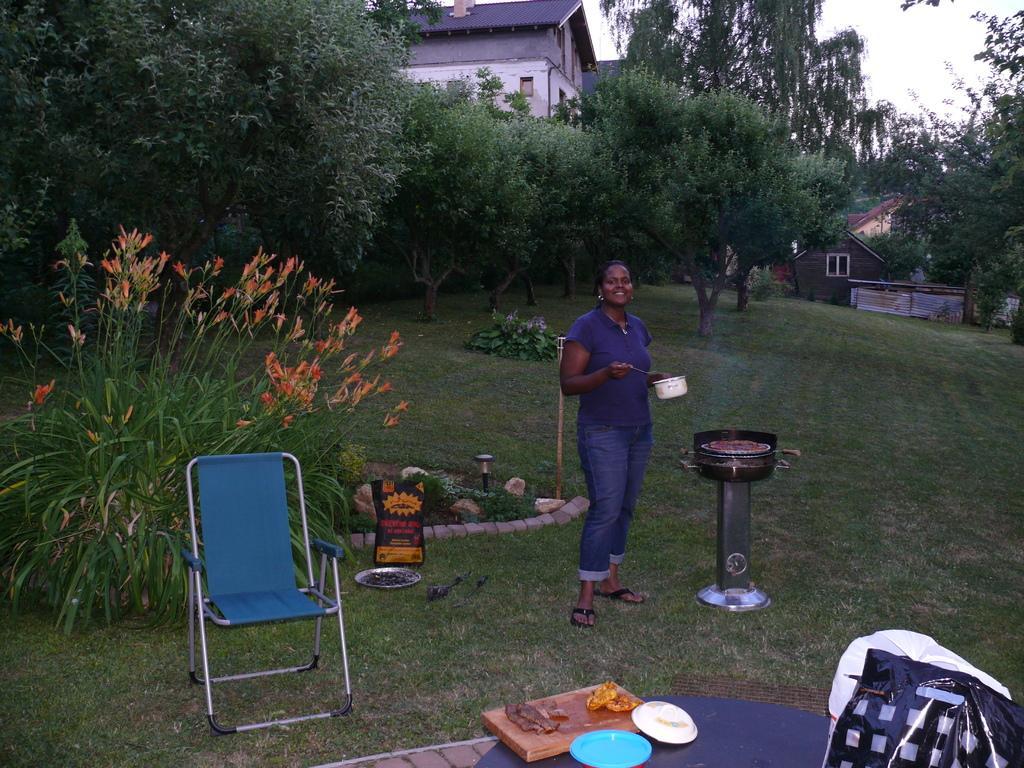Please provide a concise description of this image. In this picture we can see a lady holding a thing and in front of her there is a table on which some things are placed and beside her there is a chair and around her there are some plants and grass on the floor. 